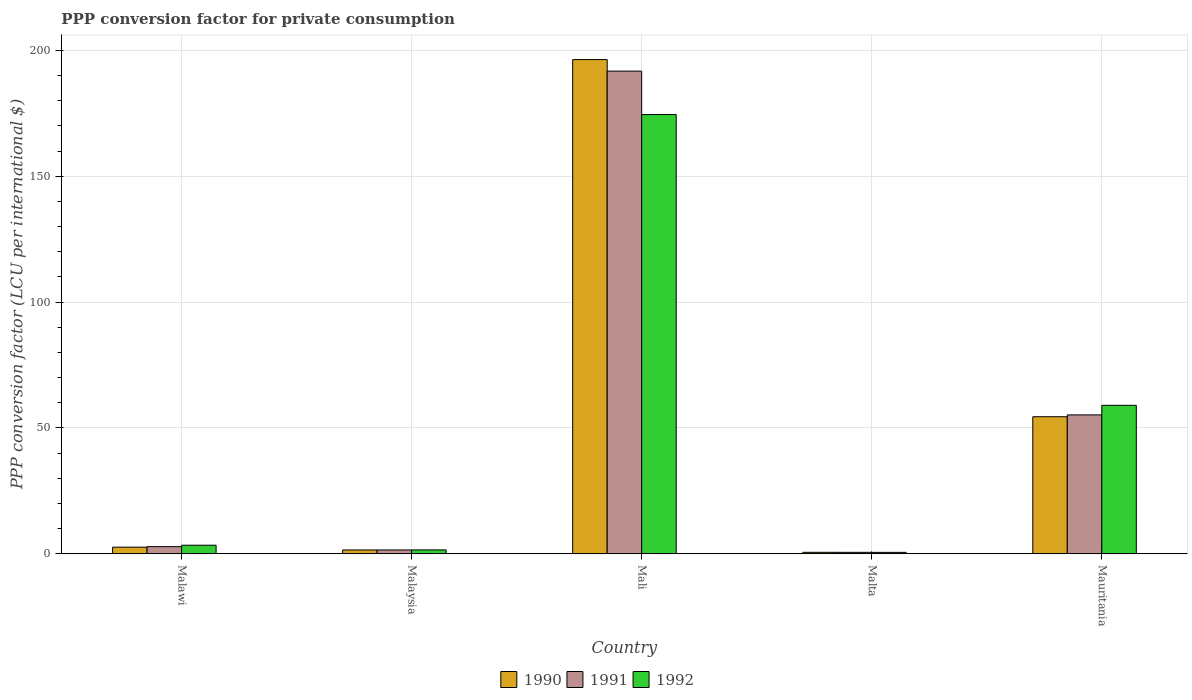How many different coloured bars are there?
Your answer should be very brief. 3. Are the number of bars per tick equal to the number of legend labels?
Provide a short and direct response. Yes. How many bars are there on the 2nd tick from the right?
Ensure brevity in your answer.  3. What is the label of the 5th group of bars from the left?
Your answer should be compact. Mauritania. In how many cases, is the number of bars for a given country not equal to the number of legend labels?
Your answer should be compact. 0. What is the PPP conversion factor for private consumption in 1990 in Malta?
Your response must be concise. 0.57. Across all countries, what is the maximum PPP conversion factor for private consumption in 1990?
Offer a terse response. 196.35. Across all countries, what is the minimum PPP conversion factor for private consumption in 1990?
Offer a very short reply. 0.57. In which country was the PPP conversion factor for private consumption in 1992 maximum?
Provide a short and direct response. Mali. In which country was the PPP conversion factor for private consumption in 1990 minimum?
Give a very brief answer. Malta. What is the total PPP conversion factor for private consumption in 1991 in the graph?
Give a very brief answer. 251.82. What is the difference between the PPP conversion factor for private consumption in 1990 in Malawi and that in Malaysia?
Ensure brevity in your answer.  1.11. What is the difference between the PPP conversion factor for private consumption in 1992 in Malaysia and the PPP conversion factor for private consumption in 1990 in Mauritania?
Offer a terse response. -52.91. What is the average PPP conversion factor for private consumption in 1990 per country?
Provide a succinct answer. 51.09. What is the difference between the PPP conversion factor for private consumption of/in 1991 and PPP conversion factor for private consumption of/in 1992 in Mauritania?
Keep it short and to the point. -3.81. In how many countries, is the PPP conversion factor for private consumption in 1991 greater than 80 LCU?
Ensure brevity in your answer.  1. What is the ratio of the PPP conversion factor for private consumption in 1990 in Malawi to that in Malta?
Your answer should be very brief. 4.61. Is the difference between the PPP conversion factor for private consumption in 1991 in Malawi and Malaysia greater than the difference between the PPP conversion factor for private consumption in 1992 in Malawi and Malaysia?
Make the answer very short. No. What is the difference between the highest and the second highest PPP conversion factor for private consumption in 1992?
Make the answer very short. 55.58. What is the difference between the highest and the lowest PPP conversion factor for private consumption in 1992?
Give a very brief answer. 173.95. In how many countries, is the PPP conversion factor for private consumption in 1991 greater than the average PPP conversion factor for private consumption in 1991 taken over all countries?
Provide a short and direct response. 2. What does the 3rd bar from the left in Malaysia represents?
Offer a terse response. 1992. What does the 1st bar from the right in Malta represents?
Make the answer very short. 1992. Is it the case that in every country, the sum of the PPP conversion factor for private consumption in 1991 and PPP conversion factor for private consumption in 1992 is greater than the PPP conversion factor for private consumption in 1990?
Provide a succinct answer. Yes. How many bars are there?
Provide a succinct answer. 15. What is the difference between two consecutive major ticks on the Y-axis?
Give a very brief answer. 50. Are the values on the major ticks of Y-axis written in scientific E-notation?
Your answer should be very brief. No. Does the graph contain grids?
Keep it short and to the point. Yes. What is the title of the graph?
Keep it short and to the point. PPP conversion factor for private consumption. What is the label or title of the X-axis?
Offer a very short reply. Country. What is the label or title of the Y-axis?
Give a very brief answer. PPP conversion factor (LCU per international $). What is the PPP conversion factor (LCU per international $) in 1990 in Malawi?
Ensure brevity in your answer.  2.62. What is the PPP conversion factor (LCU per international $) of 1991 in Malawi?
Make the answer very short. 2.83. What is the PPP conversion factor (LCU per international $) in 1992 in Malawi?
Provide a succinct answer. 3.39. What is the PPP conversion factor (LCU per international $) in 1990 in Malaysia?
Ensure brevity in your answer.  1.5. What is the PPP conversion factor (LCU per international $) of 1991 in Malaysia?
Give a very brief answer. 1.5. What is the PPP conversion factor (LCU per international $) in 1992 in Malaysia?
Give a very brief answer. 1.53. What is the PPP conversion factor (LCU per international $) of 1990 in Mali?
Ensure brevity in your answer.  196.35. What is the PPP conversion factor (LCU per international $) in 1991 in Mali?
Your answer should be very brief. 191.76. What is the PPP conversion factor (LCU per international $) in 1992 in Mali?
Ensure brevity in your answer.  174.51. What is the PPP conversion factor (LCU per international $) of 1990 in Malta?
Ensure brevity in your answer.  0.57. What is the PPP conversion factor (LCU per international $) of 1991 in Malta?
Provide a succinct answer. 0.56. What is the PPP conversion factor (LCU per international $) of 1992 in Malta?
Make the answer very short. 0.55. What is the PPP conversion factor (LCU per international $) in 1990 in Mauritania?
Offer a terse response. 54.44. What is the PPP conversion factor (LCU per international $) of 1991 in Mauritania?
Provide a succinct answer. 55.17. What is the PPP conversion factor (LCU per international $) in 1992 in Mauritania?
Make the answer very short. 58.98. Across all countries, what is the maximum PPP conversion factor (LCU per international $) of 1990?
Your answer should be very brief. 196.35. Across all countries, what is the maximum PPP conversion factor (LCU per international $) of 1991?
Ensure brevity in your answer.  191.76. Across all countries, what is the maximum PPP conversion factor (LCU per international $) of 1992?
Your answer should be very brief. 174.51. Across all countries, what is the minimum PPP conversion factor (LCU per international $) of 1990?
Your answer should be compact. 0.57. Across all countries, what is the minimum PPP conversion factor (LCU per international $) in 1991?
Provide a short and direct response. 0.56. Across all countries, what is the minimum PPP conversion factor (LCU per international $) of 1992?
Your answer should be compact. 0.55. What is the total PPP conversion factor (LCU per international $) of 1990 in the graph?
Offer a very short reply. 255.47. What is the total PPP conversion factor (LCU per international $) of 1991 in the graph?
Your answer should be very brief. 251.82. What is the total PPP conversion factor (LCU per international $) of 1992 in the graph?
Your answer should be compact. 238.95. What is the difference between the PPP conversion factor (LCU per international $) in 1990 in Malawi and that in Malaysia?
Offer a very short reply. 1.11. What is the difference between the PPP conversion factor (LCU per international $) of 1991 in Malawi and that in Malaysia?
Provide a short and direct response. 1.32. What is the difference between the PPP conversion factor (LCU per international $) of 1992 in Malawi and that in Malaysia?
Offer a terse response. 1.86. What is the difference between the PPP conversion factor (LCU per international $) in 1990 in Malawi and that in Mali?
Ensure brevity in your answer.  -193.73. What is the difference between the PPP conversion factor (LCU per international $) in 1991 in Malawi and that in Mali?
Your answer should be very brief. -188.94. What is the difference between the PPP conversion factor (LCU per international $) of 1992 in Malawi and that in Mali?
Give a very brief answer. -171.11. What is the difference between the PPP conversion factor (LCU per international $) in 1990 in Malawi and that in Malta?
Provide a succinct answer. 2.05. What is the difference between the PPP conversion factor (LCU per international $) in 1991 in Malawi and that in Malta?
Your answer should be very brief. 2.27. What is the difference between the PPP conversion factor (LCU per international $) in 1992 in Malawi and that in Malta?
Give a very brief answer. 2.84. What is the difference between the PPP conversion factor (LCU per international $) in 1990 in Malawi and that in Mauritania?
Offer a very short reply. -51.82. What is the difference between the PPP conversion factor (LCU per international $) in 1991 in Malawi and that in Mauritania?
Your answer should be very brief. -52.34. What is the difference between the PPP conversion factor (LCU per international $) of 1992 in Malawi and that in Mauritania?
Your answer should be very brief. -55.58. What is the difference between the PPP conversion factor (LCU per international $) of 1990 in Malaysia and that in Mali?
Your answer should be very brief. -194.84. What is the difference between the PPP conversion factor (LCU per international $) in 1991 in Malaysia and that in Mali?
Give a very brief answer. -190.26. What is the difference between the PPP conversion factor (LCU per international $) of 1992 in Malaysia and that in Mali?
Give a very brief answer. -172.98. What is the difference between the PPP conversion factor (LCU per international $) of 1990 in Malaysia and that in Malta?
Your response must be concise. 0.94. What is the difference between the PPP conversion factor (LCU per international $) in 1991 in Malaysia and that in Malta?
Offer a very short reply. 0.95. What is the difference between the PPP conversion factor (LCU per international $) of 1990 in Malaysia and that in Mauritania?
Offer a terse response. -52.94. What is the difference between the PPP conversion factor (LCU per international $) of 1991 in Malaysia and that in Mauritania?
Offer a very short reply. -53.66. What is the difference between the PPP conversion factor (LCU per international $) in 1992 in Malaysia and that in Mauritania?
Your response must be concise. -57.45. What is the difference between the PPP conversion factor (LCU per international $) of 1990 in Mali and that in Malta?
Provide a succinct answer. 195.78. What is the difference between the PPP conversion factor (LCU per international $) of 1991 in Mali and that in Malta?
Provide a succinct answer. 191.2. What is the difference between the PPP conversion factor (LCU per international $) in 1992 in Mali and that in Malta?
Your answer should be very brief. 173.95. What is the difference between the PPP conversion factor (LCU per international $) in 1990 in Mali and that in Mauritania?
Give a very brief answer. 141.91. What is the difference between the PPP conversion factor (LCU per international $) in 1991 in Mali and that in Mauritania?
Ensure brevity in your answer.  136.59. What is the difference between the PPP conversion factor (LCU per international $) in 1992 in Mali and that in Mauritania?
Give a very brief answer. 115.53. What is the difference between the PPP conversion factor (LCU per international $) of 1990 in Malta and that in Mauritania?
Your answer should be compact. -53.87. What is the difference between the PPP conversion factor (LCU per international $) in 1991 in Malta and that in Mauritania?
Provide a succinct answer. -54.61. What is the difference between the PPP conversion factor (LCU per international $) of 1992 in Malta and that in Mauritania?
Provide a short and direct response. -58.43. What is the difference between the PPP conversion factor (LCU per international $) of 1990 in Malawi and the PPP conversion factor (LCU per international $) of 1991 in Malaysia?
Your answer should be very brief. 1.11. What is the difference between the PPP conversion factor (LCU per international $) in 1990 in Malawi and the PPP conversion factor (LCU per international $) in 1992 in Malaysia?
Keep it short and to the point. 1.09. What is the difference between the PPP conversion factor (LCU per international $) of 1991 in Malawi and the PPP conversion factor (LCU per international $) of 1992 in Malaysia?
Make the answer very short. 1.3. What is the difference between the PPP conversion factor (LCU per international $) of 1990 in Malawi and the PPP conversion factor (LCU per international $) of 1991 in Mali?
Give a very brief answer. -189.15. What is the difference between the PPP conversion factor (LCU per international $) of 1990 in Malawi and the PPP conversion factor (LCU per international $) of 1992 in Mali?
Provide a short and direct response. -171.89. What is the difference between the PPP conversion factor (LCU per international $) in 1991 in Malawi and the PPP conversion factor (LCU per international $) in 1992 in Mali?
Ensure brevity in your answer.  -171.68. What is the difference between the PPP conversion factor (LCU per international $) in 1990 in Malawi and the PPP conversion factor (LCU per international $) in 1991 in Malta?
Give a very brief answer. 2.06. What is the difference between the PPP conversion factor (LCU per international $) in 1990 in Malawi and the PPP conversion factor (LCU per international $) in 1992 in Malta?
Offer a terse response. 2.06. What is the difference between the PPP conversion factor (LCU per international $) of 1991 in Malawi and the PPP conversion factor (LCU per international $) of 1992 in Malta?
Keep it short and to the point. 2.27. What is the difference between the PPP conversion factor (LCU per international $) in 1990 in Malawi and the PPP conversion factor (LCU per international $) in 1991 in Mauritania?
Provide a short and direct response. -52.55. What is the difference between the PPP conversion factor (LCU per international $) in 1990 in Malawi and the PPP conversion factor (LCU per international $) in 1992 in Mauritania?
Ensure brevity in your answer.  -56.36. What is the difference between the PPP conversion factor (LCU per international $) of 1991 in Malawi and the PPP conversion factor (LCU per international $) of 1992 in Mauritania?
Your answer should be compact. -56.15. What is the difference between the PPP conversion factor (LCU per international $) of 1990 in Malaysia and the PPP conversion factor (LCU per international $) of 1991 in Mali?
Keep it short and to the point. -190.26. What is the difference between the PPP conversion factor (LCU per international $) of 1990 in Malaysia and the PPP conversion factor (LCU per international $) of 1992 in Mali?
Provide a short and direct response. -173. What is the difference between the PPP conversion factor (LCU per international $) of 1991 in Malaysia and the PPP conversion factor (LCU per international $) of 1992 in Mali?
Ensure brevity in your answer.  -173. What is the difference between the PPP conversion factor (LCU per international $) in 1990 in Malaysia and the PPP conversion factor (LCU per international $) in 1991 in Malta?
Give a very brief answer. 0.94. What is the difference between the PPP conversion factor (LCU per international $) of 1990 in Malaysia and the PPP conversion factor (LCU per international $) of 1992 in Malta?
Your answer should be compact. 0.95. What is the difference between the PPP conversion factor (LCU per international $) in 1991 in Malaysia and the PPP conversion factor (LCU per international $) in 1992 in Malta?
Ensure brevity in your answer.  0.95. What is the difference between the PPP conversion factor (LCU per international $) of 1990 in Malaysia and the PPP conversion factor (LCU per international $) of 1991 in Mauritania?
Make the answer very short. -53.67. What is the difference between the PPP conversion factor (LCU per international $) in 1990 in Malaysia and the PPP conversion factor (LCU per international $) in 1992 in Mauritania?
Give a very brief answer. -57.47. What is the difference between the PPP conversion factor (LCU per international $) in 1991 in Malaysia and the PPP conversion factor (LCU per international $) in 1992 in Mauritania?
Your answer should be compact. -57.47. What is the difference between the PPP conversion factor (LCU per international $) in 1990 in Mali and the PPP conversion factor (LCU per international $) in 1991 in Malta?
Keep it short and to the point. 195.79. What is the difference between the PPP conversion factor (LCU per international $) in 1990 in Mali and the PPP conversion factor (LCU per international $) in 1992 in Malta?
Ensure brevity in your answer.  195.8. What is the difference between the PPP conversion factor (LCU per international $) of 1991 in Mali and the PPP conversion factor (LCU per international $) of 1992 in Malta?
Your response must be concise. 191.21. What is the difference between the PPP conversion factor (LCU per international $) in 1990 in Mali and the PPP conversion factor (LCU per international $) in 1991 in Mauritania?
Your answer should be compact. 141.18. What is the difference between the PPP conversion factor (LCU per international $) in 1990 in Mali and the PPP conversion factor (LCU per international $) in 1992 in Mauritania?
Your response must be concise. 137.37. What is the difference between the PPP conversion factor (LCU per international $) of 1991 in Mali and the PPP conversion factor (LCU per international $) of 1992 in Mauritania?
Give a very brief answer. 132.78. What is the difference between the PPP conversion factor (LCU per international $) in 1990 in Malta and the PPP conversion factor (LCU per international $) in 1991 in Mauritania?
Ensure brevity in your answer.  -54.6. What is the difference between the PPP conversion factor (LCU per international $) in 1990 in Malta and the PPP conversion factor (LCU per international $) in 1992 in Mauritania?
Your answer should be compact. -58.41. What is the difference between the PPP conversion factor (LCU per international $) in 1991 in Malta and the PPP conversion factor (LCU per international $) in 1992 in Mauritania?
Provide a succinct answer. -58.42. What is the average PPP conversion factor (LCU per international $) in 1990 per country?
Make the answer very short. 51.09. What is the average PPP conversion factor (LCU per international $) in 1991 per country?
Provide a succinct answer. 50.36. What is the average PPP conversion factor (LCU per international $) in 1992 per country?
Your answer should be very brief. 47.79. What is the difference between the PPP conversion factor (LCU per international $) of 1990 and PPP conversion factor (LCU per international $) of 1991 in Malawi?
Provide a short and direct response. -0.21. What is the difference between the PPP conversion factor (LCU per international $) of 1990 and PPP conversion factor (LCU per international $) of 1992 in Malawi?
Your answer should be very brief. -0.78. What is the difference between the PPP conversion factor (LCU per international $) in 1991 and PPP conversion factor (LCU per international $) in 1992 in Malawi?
Your response must be concise. -0.57. What is the difference between the PPP conversion factor (LCU per international $) in 1990 and PPP conversion factor (LCU per international $) in 1991 in Malaysia?
Provide a short and direct response. -0. What is the difference between the PPP conversion factor (LCU per international $) in 1990 and PPP conversion factor (LCU per international $) in 1992 in Malaysia?
Provide a succinct answer. -0.03. What is the difference between the PPP conversion factor (LCU per international $) in 1991 and PPP conversion factor (LCU per international $) in 1992 in Malaysia?
Your answer should be compact. -0.03. What is the difference between the PPP conversion factor (LCU per international $) in 1990 and PPP conversion factor (LCU per international $) in 1991 in Mali?
Offer a terse response. 4.59. What is the difference between the PPP conversion factor (LCU per international $) of 1990 and PPP conversion factor (LCU per international $) of 1992 in Mali?
Keep it short and to the point. 21.84. What is the difference between the PPP conversion factor (LCU per international $) in 1991 and PPP conversion factor (LCU per international $) in 1992 in Mali?
Make the answer very short. 17.26. What is the difference between the PPP conversion factor (LCU per international $) of 1990 and PPP conversion factor (LCU per international $) of 1991 in Malta?
Keep it short and to the point. 0.01. What is the difference between the PPP conversion factor (LCU per international $) of 1990 and PPP conversion factor (LCU per international $) of 1992 in Malta?
Your answer should be compact. 0.02. What is the difference between the PPP conversion factor (LCU per international $) of 1991 and PPP conversion factor (LCU per international $) of 1992 in Malta?
Your answer should be very brief. 0.01. What is the difference between the PPP conversion factor (LCU per international $) of 1990 and PPP conversion factor (LCU per international $) of 1991 in Mauritania?
Your answer should be very brief. -0.73. What is the difference between the PPP conversion factor (LCU per international $) in 1990 and PPP conversion factor (LCU per international $) in 1992 in Mauritania?
Give a very brief answer. -4.54. What is the difference between the PPP conversion factor (LCU per international $) of 1991 and PPP conversion factor (LCU per international $) of 1992 in Mauritania?
Your answer should be very brief. -3.81. What is the ratio of the PPP conversion factor (LCU per international $) of 1990 in Malawi to that in Malaysia?
Provide a succinct answer. 1.74. What is the ratio of the PPP conversion factor (LCU per international $) of 1991 in Malawi to that in Malaysia?
Your answer should be very brief. 1.88. What is the ratio of the PPP conversion factor (LCU per international $) of 1992 in Malawi to that in Malaysia?
Ensure brevity in your answer.  2.22. What is the ratio of the PPP conversion factor (LCU per international $) in 1990 in Malawi to that in Mali?
Offer a terse response. 0.01. What is the ratio of the PPP conversion factor (LCU per international $) in 1991 in Malawi to that in Mali?
Make the answer very short. 0.01. What is the ratio of the PPP conversion factor (LCU per international $) in 1992 in Malawi to that in Mali?
Make the answer very short. 0.02. What is the ratio of the PPP conversion factor (LCU per international $) of 1990 in Malawi to that in Malta?
Offer a terse response. 4.61. What is the ratio of the PPP conversion factor (LCU per international $) of 1991 in Malawi to that in Malta?
Keep it short and to the point. 5.06. What is the ratio of the PPP conversion factor (LCU per international $) of 1992 in Malawi to that in Malta?
Provide a succinct answer. 6.17. What is the ratio of the PPP conversion factor (LCU per international $) in 1990 in Malawi to that in Mauritania?
Your answer should be very brief. 0.05. What is the ratio of the PPP conversion factor (LCU per international $) in 1991 in Malawi to that in Mauritania?
Ensure brevity in your answer.  0.05. What is the ratio of the PPP conversion factor (LCU per international $) of 1992 in Malawi to that in Mauritania?
Provide a succinct answer. 0.06. What is the ratio of the PPP conversion factor (LCU per international $) in 1990 in Malaysia to that in Mali?
Offer a terse response. 0.01. What is the ratio of the PPP conversion factor (LCU per international $) of 1991 in Malaysia to that in Mali?
Keep it short and to the point. 0.01. What is the ratio of the PPP conversion factor (LCU per international $) in 1992 in Malaysia to that in Mali?
Your answer should be compact. 0.01. What is the ratio of the PPP conversion factor (LCU per international $) in 1990 in Malaysia to that in Malta?
Ensure brevity in your answer.  2.65. What is the ratio of the PPP conversion factor (LCU per international $) of 1991 in Malaysia to that in Malta?
Provide a short and direct response. 2.7. What is the ratio of the PPP conversion factor (LCU per international $) of 1992 in Malaysia to that in Malta?
Keep it short and to the point. 2.78. What is the ratio of the PPP conversion factor (LCU per international $) of 1990 in Malaysia to that in Mauritania?
Offer a terse response. 0.03. What is the ratio of the PPP conversion factor (LCU per international $) in 1991 in Malaysia to that in Mauritania?
Your answer should be very brief. 0.03. What is the ratio of the PPP conversion factor (LCU per international $) of 1992 in Malaysia to that in Mauritania?
Your response must be concise. 0.03. What is the ratio of the PPP conversion factor (LCU per international $) in 1990 in Mali to that in Malta?
Your answer should be very brief. 346.22. What is the ratio of the PPP conversion factor (LCU per international $) in 1991 in Mali to that in Malta?
Ensure brevity in your answer.  343.72. What is the ratio of the PPP conversion factor (LCU per international $) in 1992 in Mali to that in Malta?
Make the answer very short. 317.08. What is the ratio of the PPP conversion factor (LCU per international $) in 1990 in Mali to that in Mauritania?
Provide a succinct answer. 3.61. What is the ratio of the PPP conversion factor (LCU per international $) in 1991 in Mali to that in Mauritania?
Your answer should be compact. 3.48. What is the ratio of the PPP conversion factor (LCU per international $) in 1992 in Mali to that in Mauritania?
Ensure brevity in your answer.  2.96. What is the ratio of the PPP conversion factor (LCU per international $) of 1990 in Malta to that in Mauritania?
Provide a succinct answer. 0.01. What is the ratio of the PPP conversion factor (LCU per international $) of 1991 in Malta to that in Mauritania?
Provide a short and direct response. 0.01. What is the ratio of the PPP conversion factor (LCU per international $) of 1992 in Malta to that in Mauritania?
Your answer should be compact. 0.01. What is the difference between the highest and the second highest PPP conversion factor (LCU per international $) in 1990?
Provide a short and direct response. 141.91. What is the difference between the highest and the second highest PPP conversion factor (LCU per international $) of 1991?
Your answer should be very brief. 136.59. What is the difference between the highest and the second highest PPP conversion factor (LCU per international $) of 1992?
Ensure brevity in your answer.  115.53. What is the difference between the highest and the lowest PPP conversion factor (LCU per international $) in 1990?
Provide a short and direct response. 195.78. What is the difference between the highest and the lowest PPP conversion factor (LCU per international $) in 1991?
Give a very brief answer. 191.2. What is the difference between the highest and the lowest PPP conversion factor (LCU per international $) of 1992?
Provide a succinct answer. 173.95. 